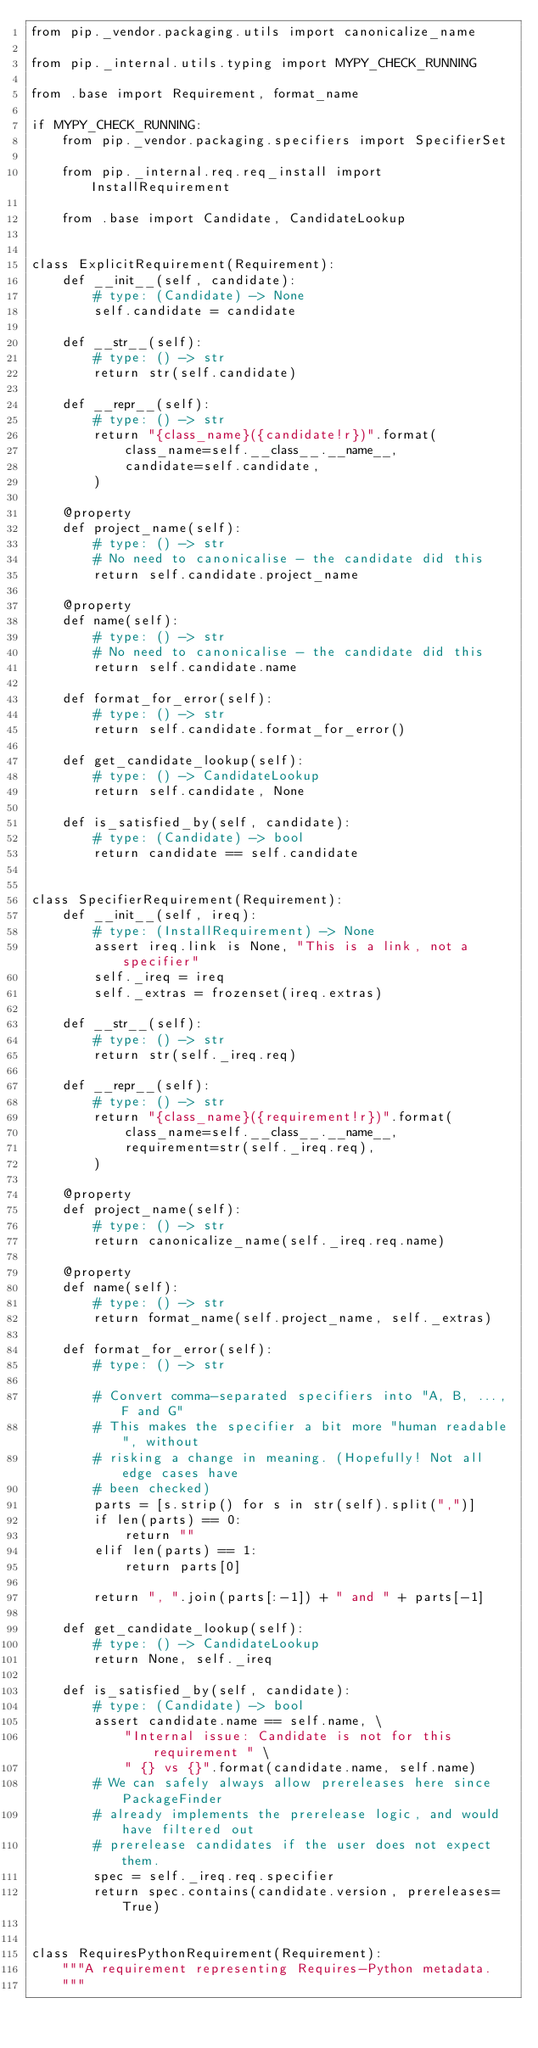<code> <loc_0><loc_0><loc_500><loc_500><_Python_>from pip._vendor.packaging.utils import canonicalize_name

from pip._internal.utils.typing import MYPY_CHECK_RUNNING

from .base import Requirement, format_name

if MYPY_CHECK_RUNNING:
    from pip._vendor.packaging.specifiers import SpecifierSet

    from pip._internal.req.req_install import InstallRequirement

    from .base import Candidate, CandidateLookup


class ExplicitRequirement(Requirement):
    def __init__(self, candidate):
        # type: (Candidate) -> None
        self.candidate = candidate

    def __str__(self):
        # type: () -> str
        return str(self.candidate)

    def __repr__(self):
        # type: () -> str
        return "{class_name}({candidate!r})".format(
            class_name=self.__class__.__name__,
            candidate=self.candidate,
        )

    @property
    def project_name(self):
        # type: () -> str
        # No need to canonicalise - the candidate did this
        return self.candidate.project_name

    @property
    def name(self):
        # type: () -> str
        # No need to canonicalise - the candidate did this
        return self.candidate.name

    def format_for_error(self):
        # type: () -> str
        return self.candidate.format_for_error()

    def get_candidate_lookup(self):
        # type: () -> CandidateLookup
        return self.candidate, None

    def is_satisfied_by(self, candidate):
        # type: (Candidate) -> bool
        return candidate == self.candidate


class SpecifierRequirement(Requirement):
    def __init__(self, ireq):
        # type: (InstallRequirement) -> None
        assert ireq.link is None, "This is a link, not a specifier"
        self._ireq = ireq
        self._extras = frozenset(ireq.extras)

    def __str__(self):
        # type: () -> str
        return str(self._ireq.req)

    def __repr__(self):
        # type: () -> str
        return "{class_name}({requirement!r})".format(
            class_name=self.__class__.__name__,
            requirement=str(self._ireq.req),
        )

    @property
    def project_name(self):
        # type: () -> str
        return canonicalize_name(self._ireq.req.name)

    @property
    def name(self):
        # type: () -> str
        return format_name(self.project_name, self._extras)

    def format_for_error(self):
        # type: () -> str

        # Convert comma-separated specifiers into "A, B, ..., F and G"
        # This makes the specifier a bit more "human readable", without
        # risking a change in meaning. (Hopefully! Not all edge cases have
        # been checked)
        parts = [s.strip() for s in str(self).split(",")]
        if len(parts) == 0:
            return ""
        elif len(parts) == 1:
            return parts[0]

        return ", ".join(parts[:-1]) + " and " + parts[-1]

    def get_candidate_lookup(self):
        # type: () -> CandidateLookup
        return None, self._ireq

    def is_satisfied_by(self, candidate):
        # type: (Candidate) -> bool
        assert candidate.name == self.name, \
            "Internal issue: Candidate is not for this requirement " \
            " {} vs {}".format(candidate.name, self.name)
        # We can safely always allow prereleases here since PackageFinder
        # already implements the prerelease logic, and would have filtered out
        # prerelease candidates if the user does not expect them.
        spec = self._ireq.req.specifier
        return spec.contains(candidate.version, prereleases=True)


class RequiresPythonRequirement(Requirement):
    """A requirement representing Requires-Python metadata.
    """</code> 